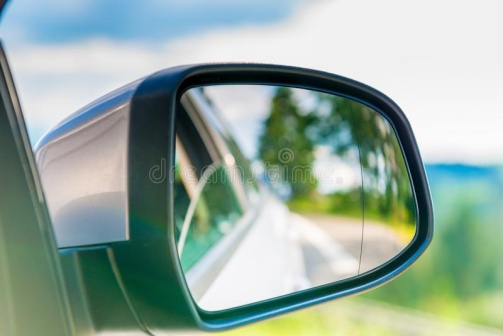What do you think is going on in this snapshot? The image presents a serene moment captured from the perspective of a car's side mirror. The side mirror, encased in a sleek black frame, reflects a winding road that stretches intriguingly into the distance, framed by vibrant green foliage. The scene suggests a peaceful drive through a lush landscape on a clear day, with a few fluffy clouds speckled across the blue sky. This snapshot not only highlights a common driving experience but also evokes a sense of tranquility and the anticipation of exploring nature's paths. 